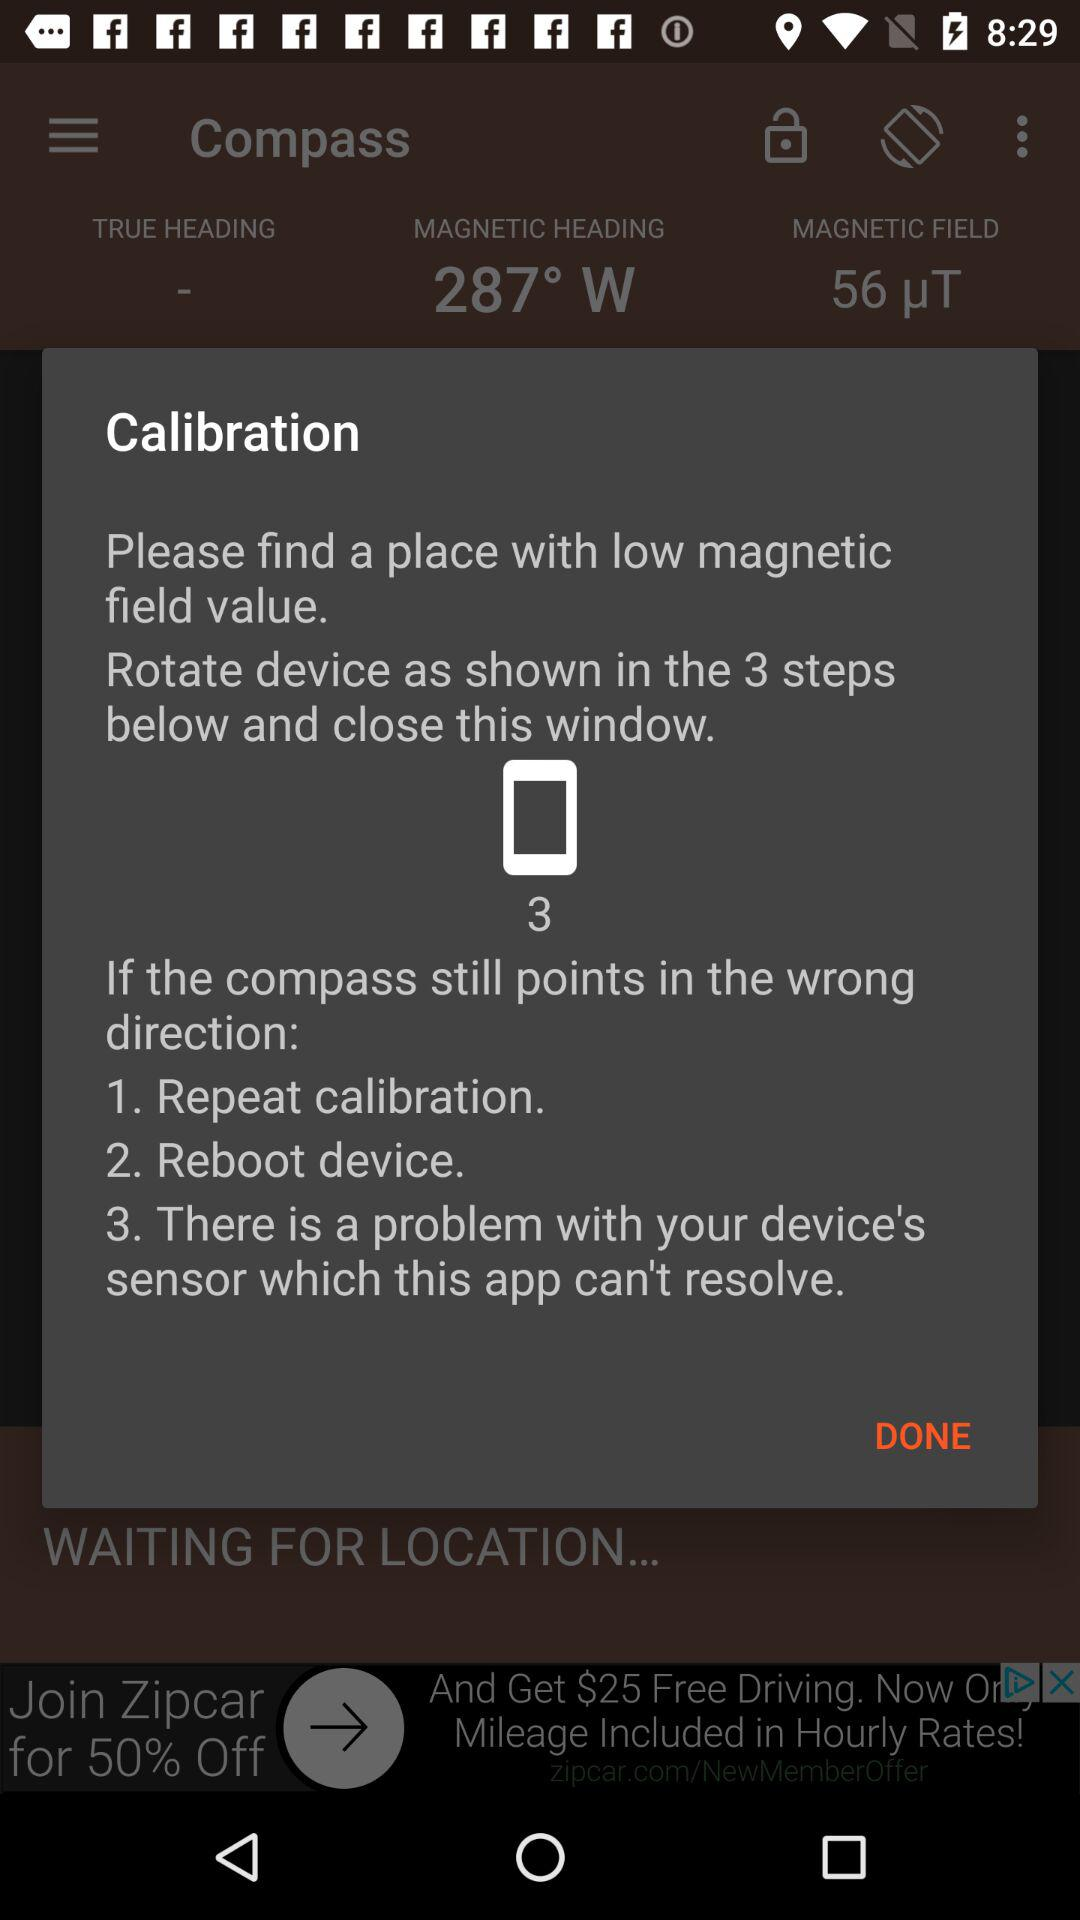What is the value of the magnetic heading? The value of the magnetic heading is 287° W. 